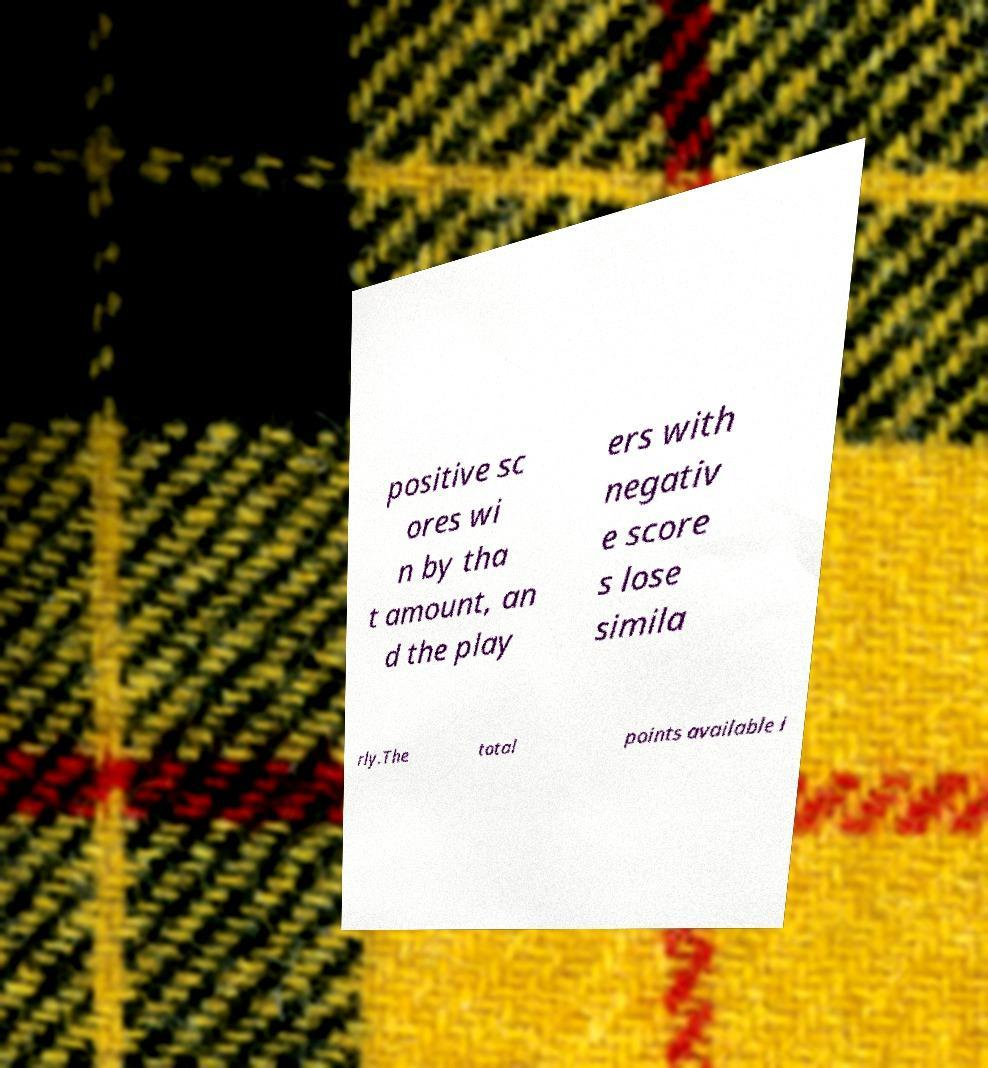What messages or text are displayed in this image? I need them in a readable, typed format. positive sc ores wi n by tha t amount, an d the play ers with negativ e score s lose simila rly.The total points available i 